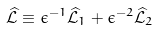<formula> <loc_0><loc_0><loc_500><loc_500>\widehat { \mathcal { L } } \equiv \epsilon ^ { - 1 } \widehat { \mathcal { L } } _ { 1 } + \epsilon ^ { - 2 } \widehat { \mathcal { L } } _ { 2 }</formula> 